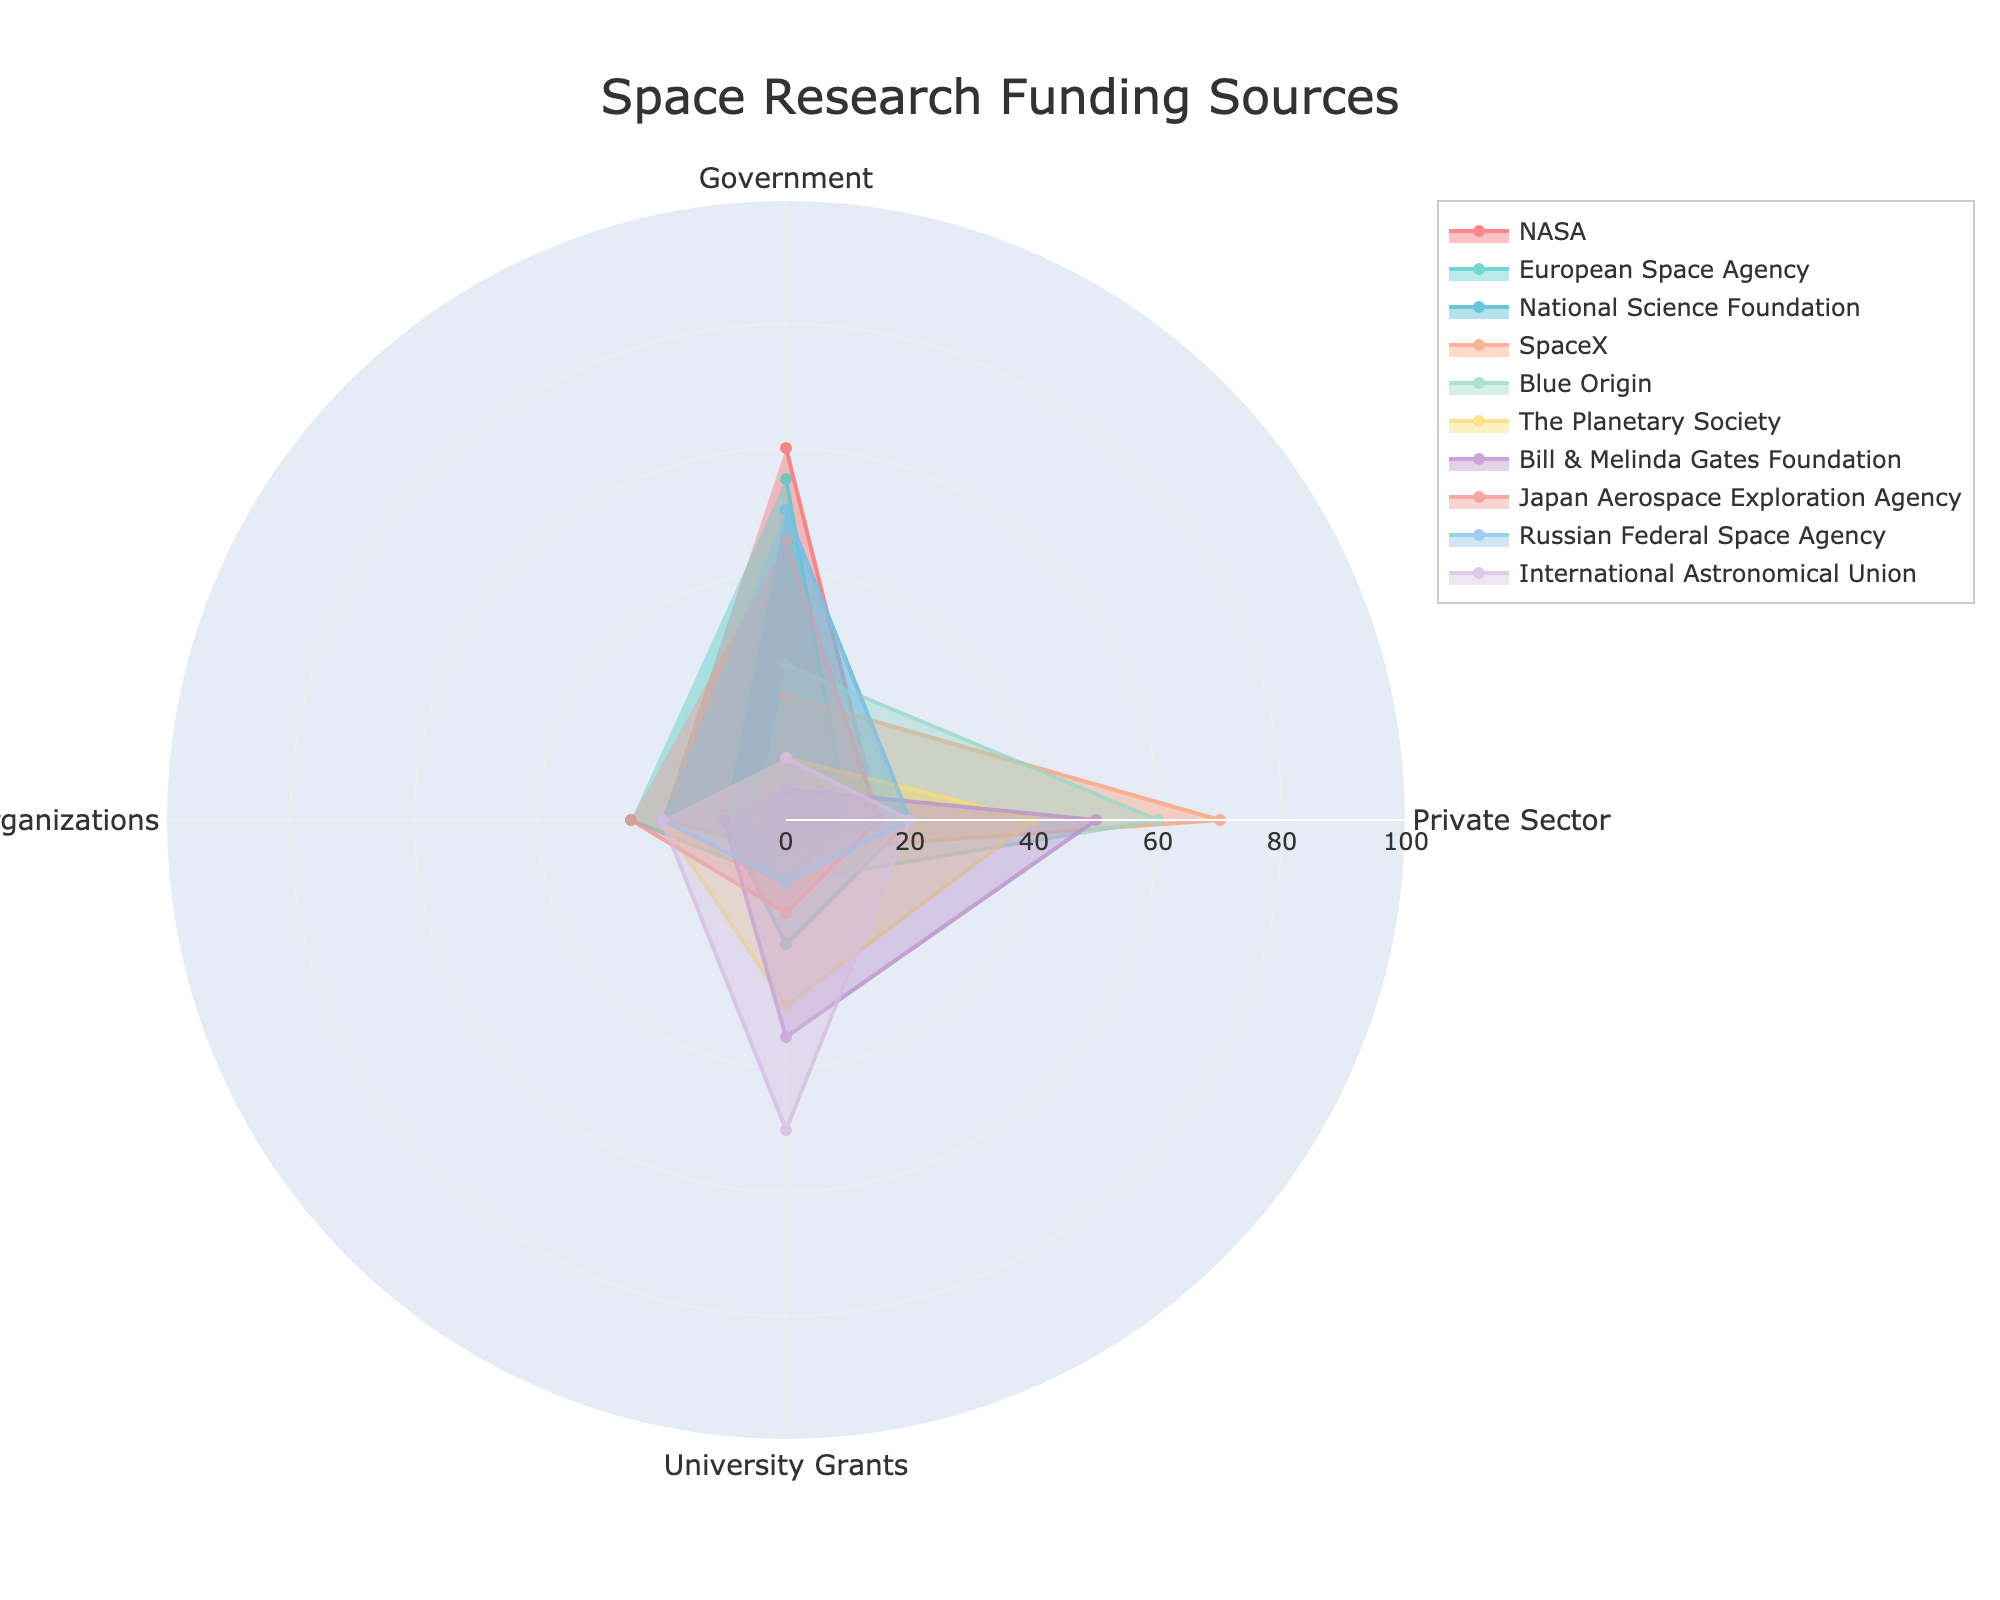What's the title of the polar chart? The title is typically found at the top center of the chart where the heading is placed. It provides a high-level summary of the chart's content.
Answer: Space Research Funding Sources How many funding sources are compared in the chart? Count the number of distinct lines or names listed in the legend. Each represents a different funding source.
Answer: 10 Which funding source has the highest percentage from the Private Sector? Look for the line or area that extends furthest towards the Private Sector category. The legend will indicate which funding source this line corresponds to.
Answer: SpaceX What is the smallest percentage contribution from Government funding among the sources? Find the segment corresponding to Government funding for each source and identify the shortest segment.
Answer: 5 (Bill & Melinda Gates Foundation) How does NASA's funding compare between Government and International Organizations? Examine the length of NASA's segments in the Government and International Organizations categories and compare their lengths.
Answer: Government is 60%, International Organizations is 20% Which funding source receives the most balanced contribution from all categories? Look for the funding source with segments of nearly equal length in all categories, indicating balanced contributions.
Answer: International Astronomical Union Calculate the average percentage of University Grants for all funding sources. Sum the percentages of University Grants for all sources and divide by the number of sources. The values are 5, 10, 20, 5, 10, 30, 35, 15, 10, 50. (5 + 10 + 20 + 5 + 10 + 30 + 35 + 15 + 10 + 50) / 10 = 19%.
Answer: 19% Which funding source has the least combined contribution from the Private Sector and University Grants? Add the percentages for Private Sector and University Grants for each source, then identify the smallest sum. Sum values: (15 + 5, 10 + 10, 20 + 20, 70 + 5, 60 + 10, 40 + 30, 50 + 35, 15 + 15, 20 + 10, 20 + 50).
Answer: Japan Aerospace Exploration Agency (15 + 15 = 30) 